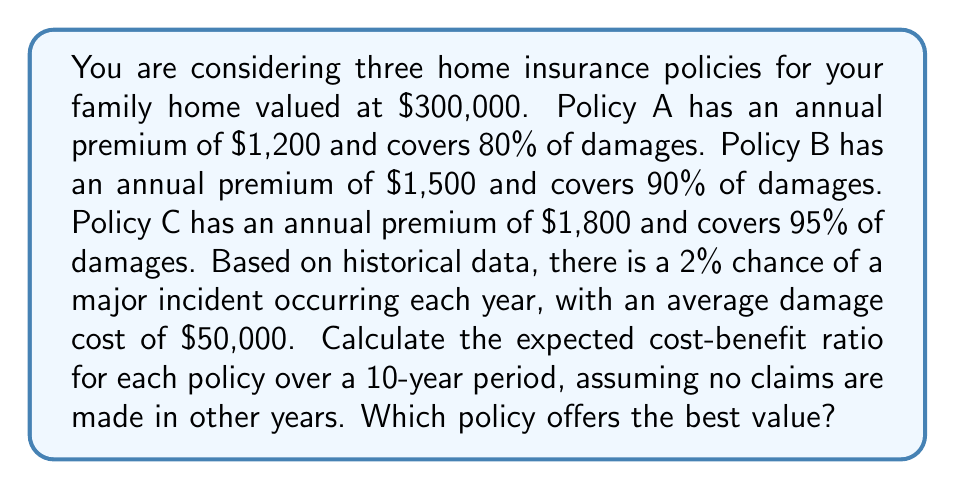Show me your answer to this math problem. Let's approach this step-by-step:

1) First, we need to calculate the expected cost of each policy over 10 years:

   For all policies: Premium cost = Annual premium × 10 years

   Policy A: $1,200 × 10 = $12,000
   Policy B: $1,500 × 10 = $15,000
   Policy C: $1,800 × 10 = $18,000

2) Now, let's calculate the expected benefit. The probability of an incident in 10 years is:

   $1 - (1 - 0.02)^{10} = 0.1829$ or about 18.29%

3) Expected payout for each policy:

   Policy A: $0.1829 × $50,000 × 0.80 = $7,316
   Policy B: $0.1829 × $50,000 × 0.90 = $8,230.50
   Policy C: $0.1829 × $50,000 × 0.95 = $8,687.75

4) The cost-benefit ratio is calculated as: $\frac{\text{Expected Benefit}}{\text{Cost}}$

   Policy A: $\frac{7,316}{12,000} = 0.6097$
   Policy B: $\frac{8,230.50}{15,000} = 0.5487$
   Policy C: $\frac{8,687.75}{18,000} = 0.4827$

5) The higher the ratio, the better the value. Therefore, Policy A offers the best value with the highest cost-benefit ratio of 0.6097.
Answer: Policy A has the best cost-benefit ratio of 0.6097. 